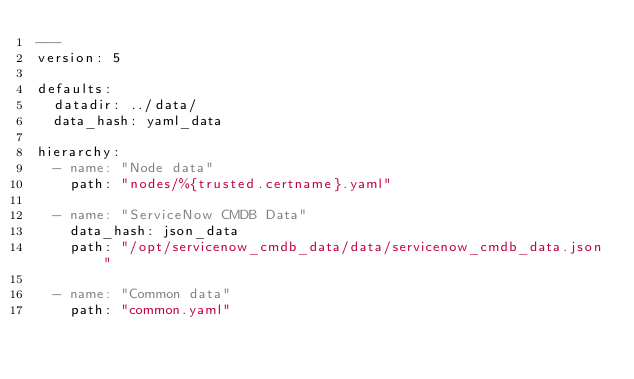<code> <loc_0><loc_0><loc_500><loc_500><_YAML_>---
version: 5

defaults:
  datadir: ../data/
  data_hash: yaml_data

hierarchy:
  - name: "Node data"
    path: "nodes/%{trusted.certname}.yaml"

  - name: "ServiceNow CMDB Data"
    data_hash: json_data
    path: "/opt/servicenow_cmdb_data/data/servicenow_cmdb_data.json"

  - name: "Common data"
    path: "common.yaml"
</code> 